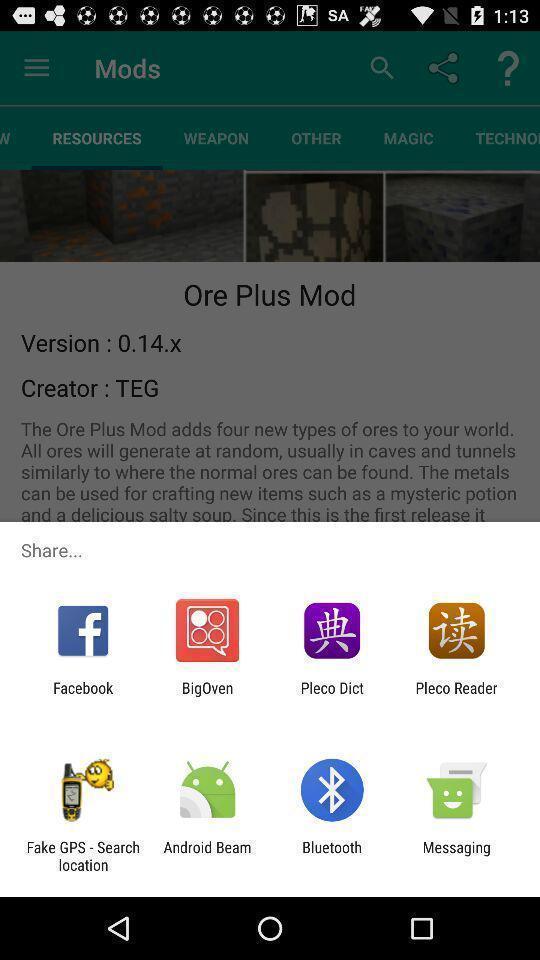Explain the elements present in this screenshot. Share information with different apps. 